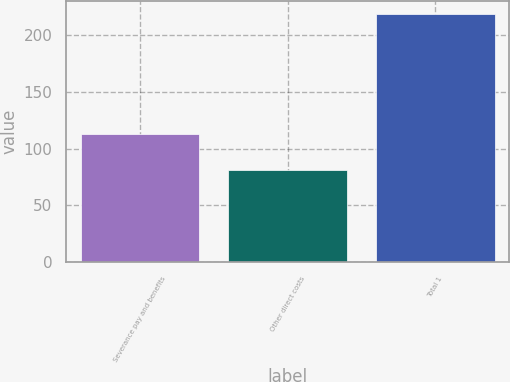Convert chart to OTSL. <chart><loc_0><loc_0><loc_500><loc_500><bar_chart><fcel>Severance pay and benefits<fcel>Other direct costs<fcel>Total 1<nl><fcel>113<fcel>81<fcel>219<nl></chart> 